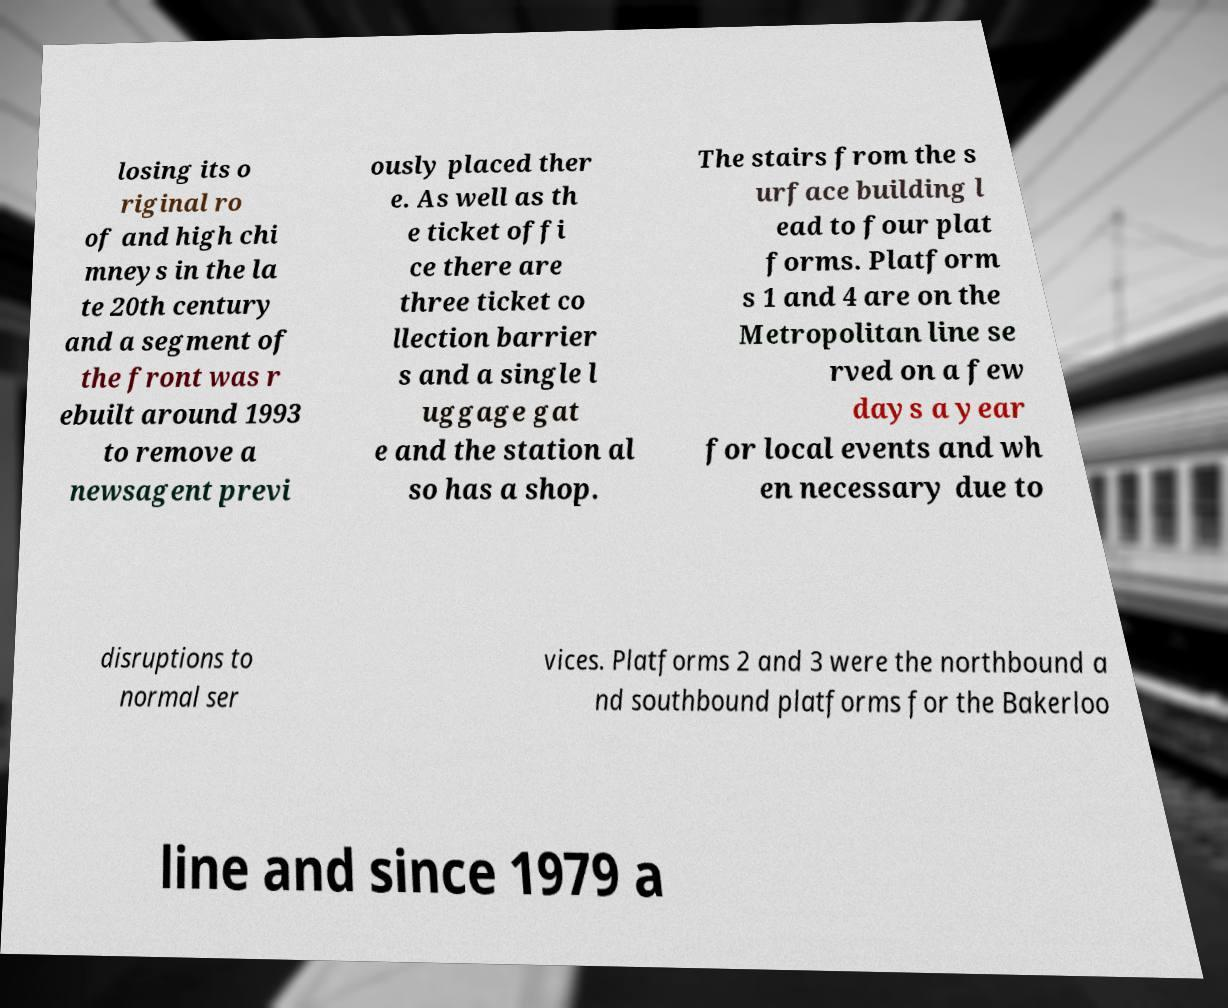Could you assist in decoding the text presented in this image and type it out clearly? losing its o riginal ro of and high chi mneys in the la te 20th century and a segment of the front was r ebuilt around 1993 to remove a newsagent previ ously placed ther e. As well as th e ticket offi ce there are three ticket co llection barrier s and a single l uggage gat e and the station al so has a shop. The stairs from the s urface building l ead to four plat forms. Platform s 1 and 4 are on the Metropolitan line se rved on a few days a year for local events and wh en necessary due to disruptions to normal ser vices. Platforms 2 and 3 were the northbound a nd southbound platforms for the Bakerloo line and since 1979 a 